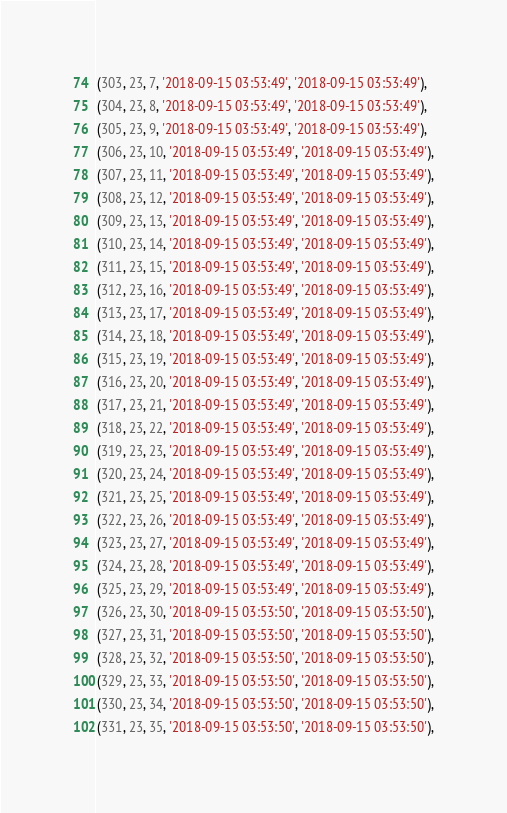<code> <loc_0><loc_0><loc_500><loc_500><_SQL_>(303, 23, 7, '2018-09-15 03:53:49', '2018-09-15 03:53:49'),
(304, 23, 8, '2018-09-15 03:53:49', '2018-09-15 03:53:49'),
(305, 23, 9, '2018-09-15 03:53:49', '2018-09-15 03:53:49'),
(306, 23, 10, '2018-09-15 03:53:49', '2018-09-15 03:53:49'),
(307, 23, 11, '2018-09-15 03:53:49', '2018-09-15 03:53:49'),
(308, 23, 12, '2018-09-15 03:53:49', '2018-09-15 03:53:49'),
(309, 23, 13, '2018-09-15 03:53:49', '2018-09-15 03:53:49'),
(310, 23, 14, '2018-09-15 03:53:49', '2018-09-15 03:53:49'),
(311, 23, 15, '2018-09-15 03:53:49', '2018-09-15 03:53:49'),
(312, 23, 16, '2018-09-15 03:53:49', '2018-09-15 03:53:49'),
(313, 23, 17, '2018-09-15 03:53:49', '2018-09-15 03:53:49'),
(314, 23, 18, '2018-09-15 03:53:49', '2018-09-15 03:53:49'),
(315, 23, 19, '2018-09-15 03:53:49', '2018-09-15 03:53:49'),
(316, 23, 20, '2018-09-15 03:53:49', '2018-09-15 03:53:49'),
(317, 23, 21, '2018-09-15 03:53:49', '2018-09-15 03:53:49'),
(318, 23, 22, '2018-09-15 03:53:49', '2018-09-15 03:53:49'),
(319, 23, 23, '2018-09-15 03:53:49', '2018-09-15 03:53:49'),
(320, 23, 24, '2018-09-15 03:53:49', '2018-09-15 03:53:49'),
(321, 23, 25, '2018-09-15 03:53:49', '2018-09-15 03:53:49'),
(322, 23, 26, '2018-09-15 03:53:49', '2018-09-15 03:53:49'),
(323, 23, 27, '2018-09-15 03:53:49', '2018-09-15 03:53:49'),
(324, 23, 28, '2018-09-15 03:53:49', '2018-09-15 03:53:49'),
(325, 23, 29, '2018-09-15 03:53:49', '2018-09-15 03:53:49'),
(326, 23, 30, '2018-09-15 03:53:50', '2018-09-15 03:53:50'),
(327, 23, 31, '2018-09-15 03:53:50', '2018-09-15 03:53:50'),
(328, 23, 32, '2018-09-15 03:53:50', '2018-09-15 03:53:50'),
(329, 23, 33, '2018-09-15 03:53:50', '2018-09-15 03:53:50'),
(330, 23, 34, '2018-09-15 03:53:50', '2018-09-15 03:53:50'),
(331, 23, 35, '2018-09-15 03:53:50', '2018-09-15 03:53:50'),</code> 